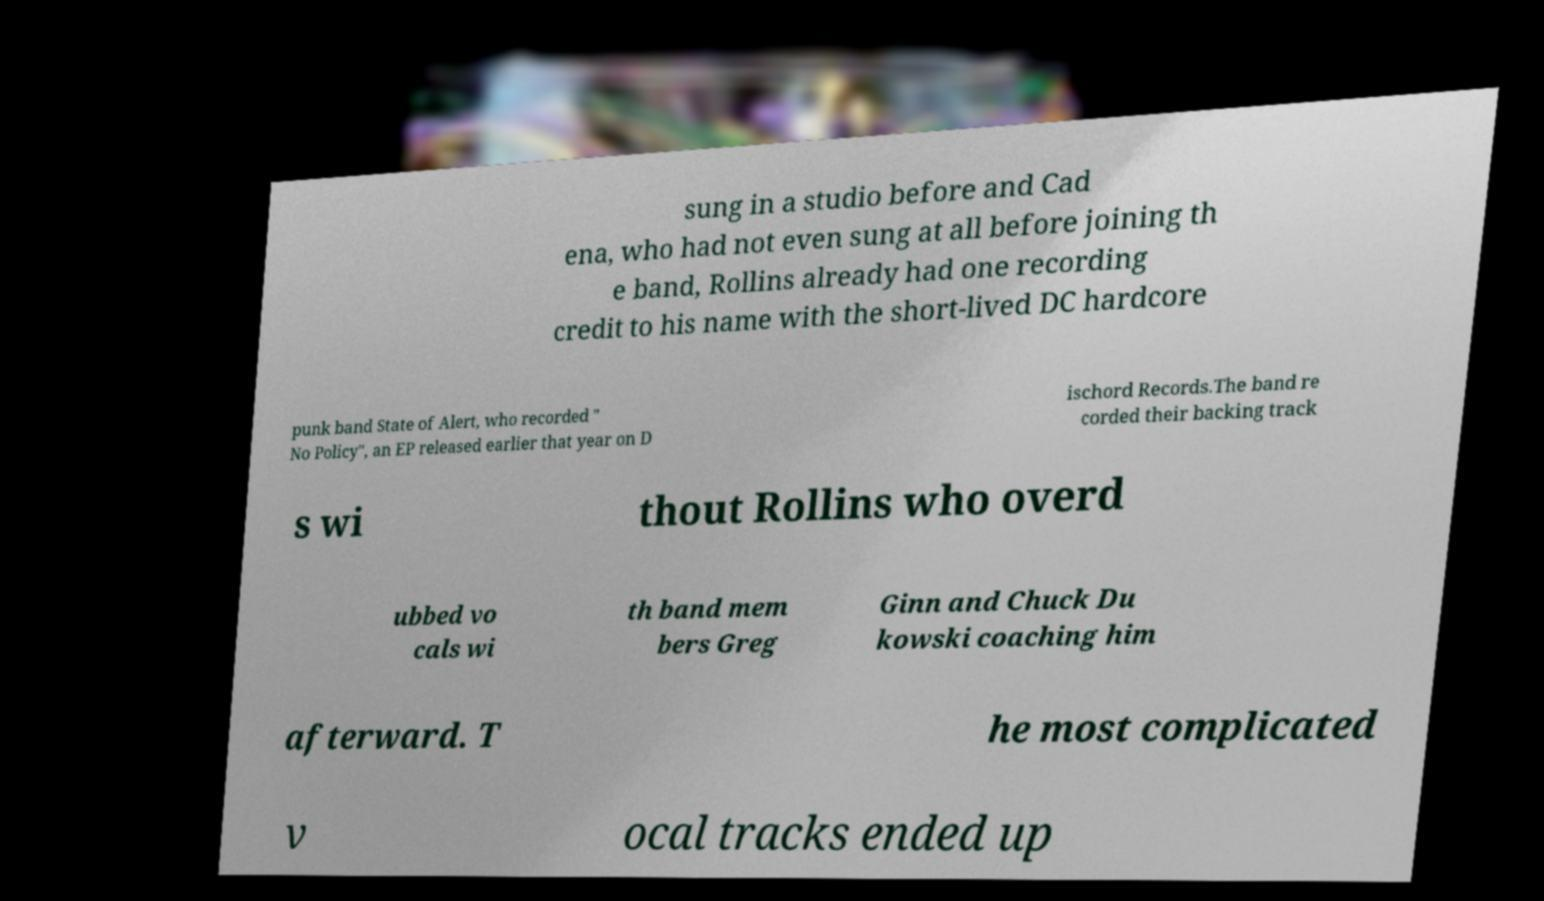Please read and relay the text visible in this image. What does it say? sung in a studio before and Cad ena, who had not even sung at all before joining th e band, Rollins already had one recording credit to his name with the short-lived DC hardcore punk band State of Alert, who recorded " No Policy", an EP released earlier that year on D ischord Records.The band re corded their backing track s wi thout Rollins who overd ubbed vo cals wi th band mem bers Greg Ginn and Chuck Du kowski coaching him afterward. T he most complicated v ocal tracks ended up 